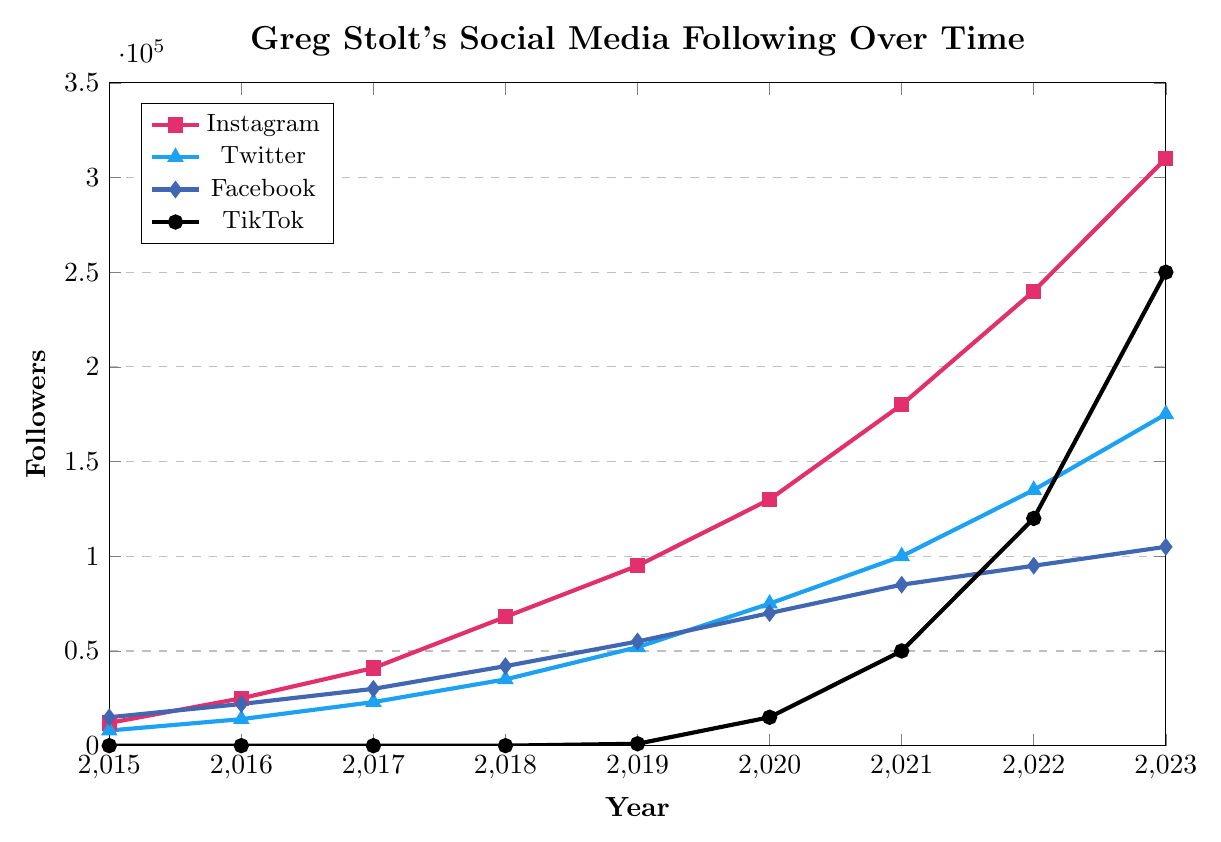Which social media platform had the most followers in 2023? Looking at the end of the lines for each platform in 2023, we can see that TikTok's line reaches the highest point, which indicates the most followers.
Answer: TikTok How many followers did Greg Stolt have in total across all platforms in 2017? To find the total, sum up the follower counts for each platform in 2017: Instagram (41,000) + Twitter (23,000) + Facebook (30,000) + TikTok (0) = 94,000
Answer: 94,000 Between which years did Greg Stolt's TikTok followers see the most significant increase? Reviewing the TikTok line, the most significant jump happens between 2022 and 2023, where followers increased from 120,000 to 250,000.
Answer: 2022-2023 Which platform saw the least growth in followers from 2015 to 2023? By comparing the growth of each platform, Facebook saw the increase from 15,000 to 105,000 (90,000 growth), which is the smallest among all platforms.
Answer: Facebook What is the difference in Instagram followers between 2020 and 2016? Subtract the 2016 follower count from the 2020 follower count: 130,000 (2020) - 25,000 (2016) = 105,000
Answer: 105,000 How did Greg Stolt's Facebook follower growth between 2015 and 2023 compare to his Twitter growth in the same period? Facebook followers grew from 15,000 to 105,000 (90,000 growth). Twitter followers grew from 8,000 to 175,000 (167,000 growth). The Twitter growth is significantly larger.
Answer: Twitter had more growth What was the average annual growth in Instagram followers from 2018 to 2020? Calculate the growth for each year and then the average: 2018 to 2019 is 95,000 - 68,000 = 27,000; 2019 to 2020 is 130,000 - 95,000 = 35,000. The average growth is (27,000 + 35,000)/2 = 31,000
Answer: 31,000 Which year did Twitter followers surpass Facebook followers? Observing the lines for Twitter and Facebook, we see that in 2017 Twitter (23,000) did not surpass Facebook (30,000), but in 2018, Twitter (35,000) surpassed Facebook (42,000).
Answer: 2018 How many total followers did Greg Stolt have across all platforms in 2015 compared to 2023? Sum up the follower counts for all platforms in 2015 and 2023 separately: 
2015: Instagram (12,000) + Twitter (8,000) + Facebook (15,000) + TikTok (0) = 35,000; 
2023: Instagram (310,000) + Twitter (175,000) + Facebook (105,000) + TikTok (250,000) = 840,000.
Answer: 840,000 in 2023, 35,000 in 2015 